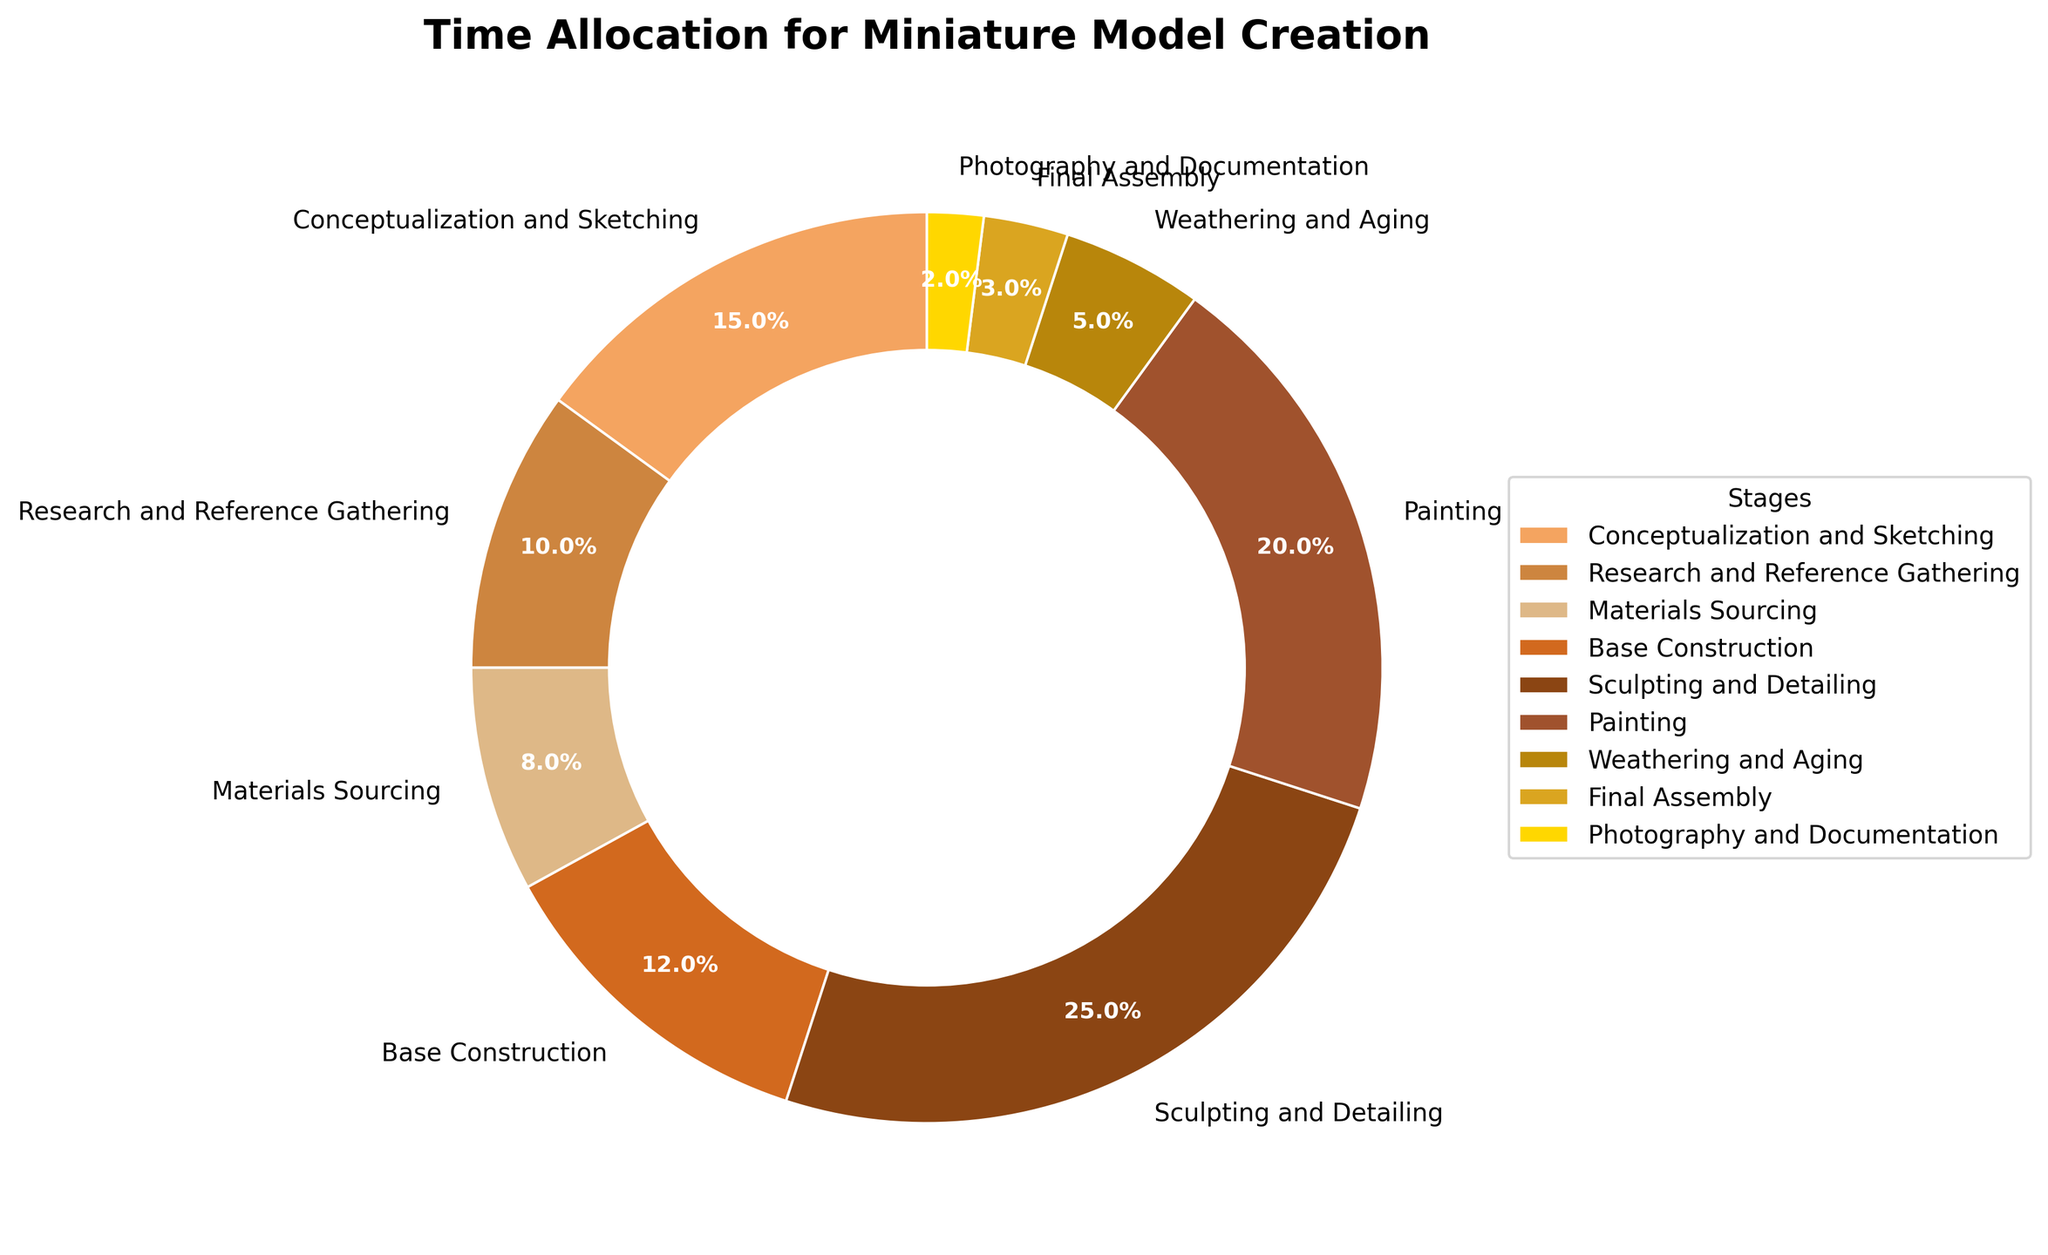what stage has the highest time allocation? Sculpting and Detailing has the highest percentage of time allocation at 25%.
Answer: Sculpting and Detailing which two stages take the least amount of time together? Final Assembly and Photography and Documentation together take the least time. Final Assembly is 3% and Photography and Documentation is 2%, adding up to 5%.
Answer: Final Assembly and Photography and Documentation how much more time is allocated to Painting compared to Materials Sourcing? Painting is allocated 20% of the time, while Materials Sourcing is allocated 8%. 20% - 8% = 12% more time is allocated to Painting.
Answer: 12% is the time spent on Conceptualization and Sketching greater than the time spent on Research and Reference Gathering and Base Construction combined? Conceptualization and Sketching is 15%. Research and Reference Gathering is 10%, and Base Construction is 12%. Combined, Research and Reference Gathering and Base Construction take 10% + 12% = 22%, which is greater than 15%.
Answer: No how does the time allocation for Weathering and Aging compare to Photography and Documentation? Weathering and Aging has 5% of time allocation, while Photography and Documentation has 2%. 5% is more than 2%.
Answer: Weathering and Aging has more time what percentage of the total time is spent on the initial stages (Conceptualization and Sketching, and Research and Reference Gathering)? Conceptualization and Sketching is 15% and Research and Reference Gathering is 10%. Adding these together gives 15% + 10% = 25%.
Answer: 25% if you combine the time spent on Sculpting and Detailing and Painting, what is the total percentage? Sculpting and Detailing takes 25%, and Painting takes 20%. Combined, they take 25% + 20% = 45%.
Answer: 45% which stage takes exactly half the time of Base Construction? Base Construction takes 12%. The stage taking half that time would be 12% / 2 = 6%. No stage is allocated exactly 6%, so none fit this criterion.
Answer: None what color represents the stage of Materials Sourcing in the pie chart? Each wedge of the pie chart is a different color. The Materials Sourcing stage is represented by a specific color. In the visual, Materials Sourcing is shown in brown.
Answer: Brown what is the difference in time allocation between the longest and shortest stages? The longest stage is Sculpting and Detailing at 25%, the shortest is Photography and Documentation at 2%. The difference is 25% - 2% = 23%.
Answer: 23% 